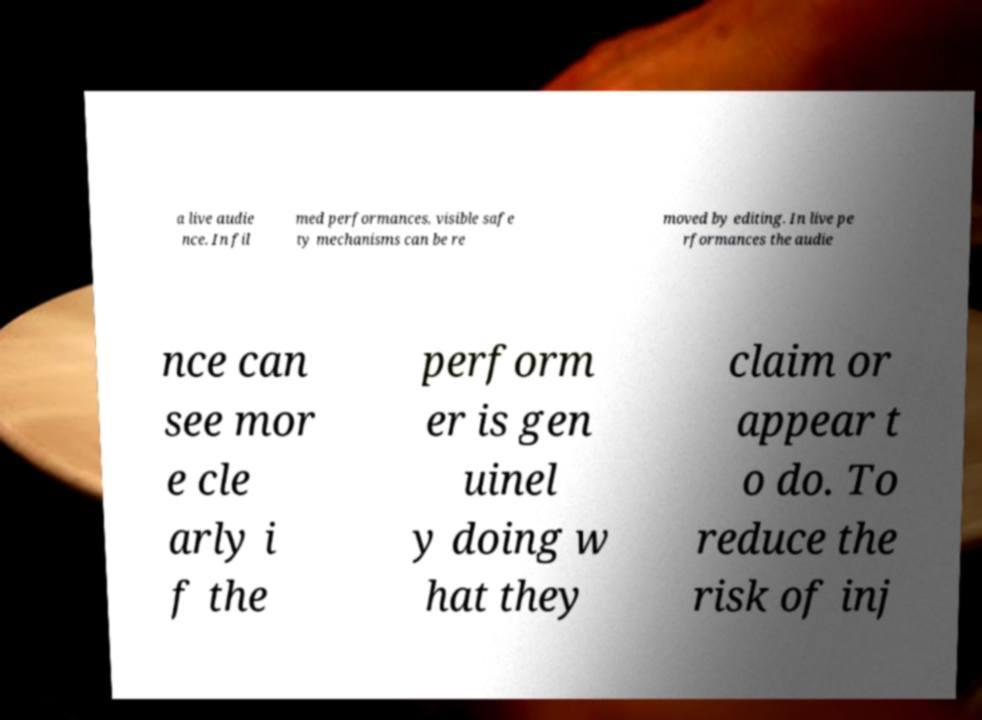What messages or text are displayed in this image? I need them in a readable, typed format. a live audie nce. In fil med performances, visible safe ty mechanisms can be re moved by editing. In live pe rformances the audie nce can see mor e cle arly i f the perform er is gen uinel y doing w hat they claim or appear t o do. To reduce the risk of inj 